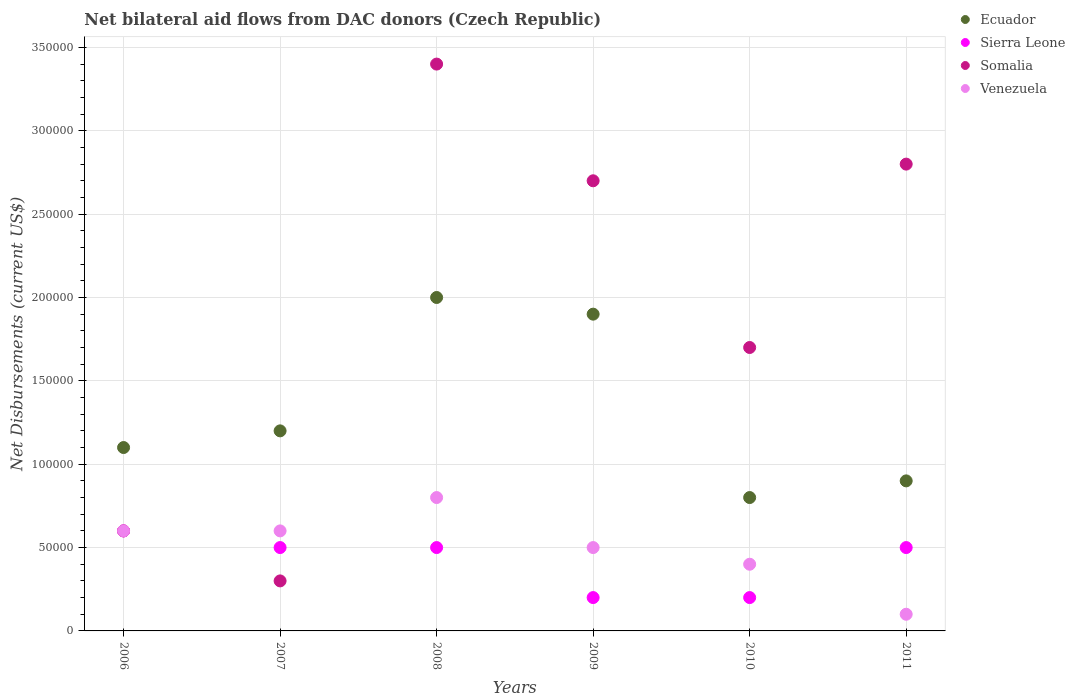Is the number of dotlines equal to the number of legend labels?
Your answer should be compact. Yes. What is the net bilateral aid flows in Somalia in 2010?
Your response must be concise. 1.70e+05. In which year was the net bilateral aid flows in Ecuador maximum?
Provide a short and direct response. 2008. What is the total net bilateral aid flows in Sierra Leone in the graph?
Offer a very short reply. 2.50e+05. In how many years, is the net bilateral aid flows in Ecuador greater than 340000 US$?
Make the answer very short. 0. What is the ratio of the net bilateral aid flows in Venezuela in 2007 to that in 2008?
Keep it short and to the point. 0.75. Is the net bilateral aid flows in Ecuador in 2008 less than that in 2009?
Ensure brevity in your answer.  No. Is the sum of the net bilateral aid flows in Somalia in 2007 and 2011 greater than the maximum net bilateral aid flows in Sierra Leone across all years?
Your answer should be compact. Yes. Does the net bilateral aid flows in Sierra Leone monotonically increase over the years?
Provide a short and direct response. No. Is the net bilateral aid flows in Sierra Leone strictly greater than the net bilateral aid flows in Ecuador over the years?
Make the answer very short. No. How many years are there in the graph?
Your answer should be compact. 6. Does the graph contain grids?
Keep it short and to the point. Yes. How many legend labels are there?
Provide a short and direct response. 4. How are the legend labels stacked?
Your answer should be compact. Vertical. What is the title of the graph?
Offer a terse response. Net bilateral aid flows from DAC donors (Czech Republic). Does "Cayman Islands" appear as one of the legend labels in the graph?
Your answer should be very brief. No. What is the label or title of the X-axis?
Your answer should be very brief. Years. What is the label or title of the Y-axis?
Provide a succinct answer. Net Disbursements (current US$). What is the Net Disbursements (current US$) of Sierra Leone in 2006?
Offer a terse response. 6.00e+04. What is the Net Disbursements (current US$) of Somalia in 2006?
Offer a very short reply. 6.00e+04. What is the Net Disbursements (current US$) in Ecuador in 2007?
Make the answer very short. 1.20e+05. What is the Net Disbursements (current US$) in Sierra Leone in 2007?
Give a very brief answer. 5.00e+04. What is the Net Disbursements (current US$) of Venezuela in 2007?
Keep it short and to the point. 6.00e+04. What is the Net Disbursements (current US$) of Ecuador in 2008?
Provide a short and direct response. 2.00e+05. What is the Net Disbursements (current US$) of Venezuela in 2008?
Ensure brevity in your answer.  8.00e+04. What is the Net Disbursements (current US$) in Sierra Leone in 2009?
Make the answer very short. 2.00e+04. What is the Net Disbursements (current US$) of Somalia in 2009?
Keep it short and to the point. 2.70e+05. What is the Net Disbursements (current US$) in Ecuador in 2010?
Make the answer very short. 8.00e+04. What is the Net Disbursements (current US$) of Sierra Leone in 2010?
Provide a succinct answer. 2.00e+04. What is the Net Disbursements (current US$) of Somalia in 2010?
Give a very brief answer. 1.70e+05. What is the Net Disbursements (current US$) of Ecuador in 2011?
Provide a short and direct response. 9.00e+04. What is the Net Disbursements (current US$) of Venezuela in 2011?
Keep it short and to the point. 10000. Across all years, what is the maximum Net Disbursements (current US$) of Ecuador?
Offer a very short reply. 2.00e+05. Across all years, what is the minimum Net Disbursements (current US$) of Ecuador?
Your answer should be very brief. 8.00e+04. Across all years, what is the minimum Net Disbursements (current US$) of Sierra Leone?
Give a very brief answer. 2.00e+04. What is the total Net Disbursements (current US$) in Ecuador in the graph?
Offer a terse response. 7.90e+05. What is the total Net Disbursements (current US$) in Somalia in the graph?
Give a very brief answer. 1.15e+06. What is the difference between the Net Disbursements (current US$) in Somalia in 2006 and that in 2007?
Your answer should be compact. 3.00e+04. What is the difference between the Net Disbursements (current US$) in Venezuela in 2006 and that in 2007?
Offer a very short reply. 0. What is the difference between the Net Disbursements (current US$) of Sierra Leone in 2006 and that in 2008?
Your answer should be very brief. 10000. What is the difference between the Net Disbursements (current US$) in Somalia in 2006 and that in 2008?
Offer a terse response. -2.80e+05. What is the difference between the Net Disbursements (current US$) in Venezuela in 2006 and that in 2008?
Make the answer very short. -2.00e+04. What is the difference between the Net Disbursements (current US$) in Sierra Leone in 2006 and that in 2009?
Your answer should be very brief. 4.00e+04. What is the difference between the Net Disbursements (current US$) of Ecuador in 2006 and that in 2010?
Your response must be concise. 3.00e+04. What is the difference between the Net Disbursements (current US$) of Somalia in 2006 and that in 2011?
Provide a short and direct response. -2.20e+05. What is the difference between the Net Disbursements (current US$) of Venezuela in 2006 and that in 2011?
Make the answer very short. 5.00e+04. What is the difference between the Net Disbursements (current US$) in Sierra Leone in 2007 and that in 2008?
Give a very brief answer. 0. What is the difference between the Net Disbursements (current US$) in Somalia in 2007 and that in 2008?
Keep it short and to the point. -3.10e+05. What is the difference between the Net Disbursements (current US$) in Ecuador in 2007 and that in 2009?
Ensure brevity in your answer.  -7.00e+04. What is the difference between the Net Disbursements (current US$) of Somalia in 2007 and that in 2009?
Keep it short and to the point. -2.40e+05. What is the difference between the Net Disbursements (current US$) in Venezuela in 2007 and that in 2009?
Your answer should be very brief. 10000. What is the difference between the Net Disbursements (current US$) in Ecuador in 2007 and that in 2011?
Give a very brief answer. 3.00e+04. What is the difference between the Net Disbursements (current US$) in Somalia in 2007 and that in 2011?
Provide a short and direct response. -2.50e+05. What is the difference between the Net Disbursements (current US$) in Venezuela in 2007 and that in 2011?
Make the answer very short. 5.00e+04. What is the difference between the Net Disbursements (current US$) in Sierra Leone in 2008 and that in 2009?
Your response must be concise. 3.00e+04. What is the difference between the Net Disbursements (current US$) of Venezuela in 2008 and that in 2009?
Provide a succinct answer. 3.00e+04. What is the difference between the Net Disbursements (current US$) of Ecuador in 2008 and that in 2010?
Give a very brief answer. 1.20e+05. What is the difference between the Net Disbursements (current US$) in Sierra Leone in 2008 and that in 2010?
Provide a short and direct response. 3.00e+04. What is the difference between the Net Disbursements (current US$) in Venezuela in 2008 and that in 2010?
Keep it short and to the point. 4.00e+04. What is the difference between the Net Disbursements (current US$) in Sierra Leone in 2008 and that in 2011?
Provide a short and direct response. 0. What is the difference between the Net Disbursements (current US$) in Somalia in 2008 and that in 2011?
Keep it short and to the point. 6.00e+04. What is the difference between the Net Disbursements (current US$) of Venezuela in 2008 and that in 2011?
Ensure brevity in your answer.  7.00e+04. What is the difference between the Net Disbursements (current US$) in Venezuela in 2009 and that in 2010?
Your answer should be very brief. 10000. What is the difference between the Net Disbursements (current US$) in Ecuador in 2009 and that in 2011?
Keep it short and to the point. 1.00e+05. What is the difference between the Net Disbursements (current US$) in Sierra Leone in 2009 and that in 2011?
Provide a short and direct response. -3.00e+04. What is the difference between the Net Disbursements (current US$) in Somalia in 2009 and that in 2011?
Your answer should be very brief. -10000. What is the difference between the Net Disbursements (current US$) of Ecuador in 2010 and that in 2011?
Offer a terse response. -10000. What is the difference between the Net Disbursements (current US$) in Somalia in 2010 and that in 2011?
Provide a short and direct response. -1.10e+05. What is the difference between the Net Disbursements (current US$) in Ecuador in 2006 and the Net Disbursements (current US$) in Sierra Leone in 2007?
Your answer should be very brief. 6.00e+04. What is the difference between the Net Disbursements (current US$) in Ecuador in 2006 and the Net Disbursements (current US$) in Somalia in 2007?
Provide a short and direct response. 8.00e+04. What is the difference between the Net Disbursements (current US$) in Ecuador in 2006 and the Net Disbursements (current US$) in Venezuela in 2007?
Your answer should be compact. 5.00e+04. What is the difference between the Net Disbursements (current US$) in Sierra Leone in 2006 and the Net Disbursements (current US$) in Venezuela in 2007?
Your answer should be very brief. 0. What is the difference between the Net Disbursements (current US$) of Ecuador in 2006 and the Net Disbursements (current US$) of Sierra Leone in 2008?
Make the answer very short. 6.00e+04. What is the difference between the Net Disbursements (current US$) of Ecuador in 2006 and the Net Disbursements (current US$) of Somalia in 2008?
Offer a very short reply. -2.30e+05. What is the difference between the Net Disbursements (current US$) in Sierra Leone in 2006 and the Net Disbursements (current US$) in Somalia in 2008?
Offer a terse response. -2.80e+05. What is the difference between the Net Disbursements (current US$) of Somalia in 2006 and the Net Disbursements (current US$) of Venezuela in 2008?
Give a very brief answer. -2.00e+04. What is the difference between the Net Disbursements (current US$) in Ecuador in 2006 and the Net Disbursements (current US$) in Venezuela in 2009?
Offer a terse response. 6.00e+04. What is the difference between the Net Disbursements (current US$) of Sierra Leone in 2006 and the Net Disbursements (current US$) of Somalia in 2009?
Offer a terse response. -2.10e+05. What is the difference between the Net Disbursements (current US$) of Sierra Leone in 2006 and the Net Disbursements (current US$) of Venezuela in 2009?
Your response must be concise. 10000. What is the difference between the Net Disbursements (current US$) in Somalia in 2006 and the Net Disbursements (current US$) in Venezuela in 2009?
Give a very brief answer. 10000. What is the difference between the Net Disbursements (current US$) in Ecuador in 2006 and the Net Disbursements (current US$) in Sierra Leone in 2010?
Provide a short and direct response. 9.00e+04. What is the difference between the Net Disbursements (current US$) of Ecuador in 2006 and the Net Disbursements (current US$) of Venezuela in 2010?
Offer a terse response. 7.00e+04. What is the difference between the Net Disbursements (current US$) of Sierra Leone in 2006 and the Net Disbursements (current US$) of Somalia in 2010?
Your answer should be very brief. -1.10e+05. What is the difference between the Net Disbursements (current US$) in Somalia in 2006 and the Net Disbursements (current US$) in Venezuela in 2010?
Your response must be concise. 2.00e+04. What is the difference between the Net Disbursements (current US$) of Ecuador in 2006 and the Net Disbursements (current US$) of Sierra Leone in 2011?
Keep it short and to the point. 6.00e+04. What is the difference between the Net Disbursements (current US$) in Sierra Leone in 2006 and the Net Disbursements (current US$) in Venezuela in 2011?
Your answer should be compact. 5.00e+04. What is the difference between the Net Disbursements (current US$) in Ecuador in 2007 and the Net Disbursements (current US$) in Somalia in 2008?
Offer a terse response. -2.20e+05. What is the difference between the Net Disbursements (current US$) of Sierra Leone in 2007 and the Net Disbursements (current US$) of Somalia in 2008?
Offer a terse response. -2.90e+05. What is the difference between the Net Disbursements (current US$) of Sierra Leone in 2007 and the Net Disbursements (current US$) of Venezuela in 2008?
Make the answer very short. -3.00e+04. What is the difference between the Net Disbursements (current US$) of Ecuador in 2007 and the Net Disbursements (current US$) of Sierra Leone in 2009?
Your response must be concise. 1.00e+05. What is the difference between the Net Disbursements (current US$) in Ecuador in 2007 and the Net Disbursements (current US$) in Somalia in 2010?
Provide a succinct answer. -5.00e+04. What is the difference between the Net Disbursements (current US$) of Ecuador in 2007 and the Net Disbursements (current US$) of Venezuela in 2010?
Ensure brevity in your answer.  8.00e+04. What is the difference between the Net Disbursements (current US$) in Sierra Leone in 2007 and the Net Disbursements (current US$) in Somalia in 2011?
Offer a terse response. -2.30e+05. What is the difference between the Net Disbursements (current US$) of Ecuador in 2008 and the Net Disbursements (current US$) of Somalia in 2009?
Ensure brevity in your answer.  -7.00e+04. What is the difference between the Net Disbursements (current US$) in Sierra Leone in 2008 and the Net Disbursements (current US$) in Somalia in 2009?
Offer a very short reply. -2.20e+05. What is the difference between the Net Disbursements (current US$) in Somalia in 2008 and the Net Disbursements (current US$) in Venezuela in 2009?
Offer a very short reply. 2.90e+05. What is the difference between the Net Disbursements (current US$) of Ecuador in 2008 and the Net Disbursements (current US$) of Somalia in 2010?
Provide a short and direct response. 3.00e+04. What is the difference between the Net Disbursements (current US$) in Ecuador in 2008 and the Net Disbursements (current US$) in Venezuela in 2010?
Keep it short and to the point. 1.60e+05. What is the difference between the Net Disbursements (current US$) of Somalia in 2008 and the Net Disbursements (current US$) of Venezuela in 2010?
Make the answer very short. 3.00e+05. What is the difference between the Net Disbursements (current US$) of Ecuador in 2008 and the Net Disbursements (current US$) of Sierra Leone in 2011?
Your answer should be very brief. 1.50e+05. What is the difference between the Net Disbursements (current US$) in Ecuador in 2008 and the Net Disbursements (current US$) in Somalia in 2011?
Your answer should be compact. -8.00e+04. What is the difference between the Net Disbursements (current US$) in Ecuador in 2008 and the Net Disbursements (current US$) in Venezuela in 2011?
Offer a terse response. 1.90e+05. What is the difference between the Net Disbursements (current US$) of Sierra Leone in 2008 and the Net Disbursements (current US$) of Somalia in 2011?
Keep it short and to the point. -2.30e+05. What is the difference between the Net Disbursements (current US$) of Somalia in 2008 and the Net Disbursements (current US$) of Venezuela in 2011?
Provide a succinct answer. 3.30e+05. What is the difference between the Net Disbursements (current US$) of Ecuador in 2009 and the Net Disbursements (current US$) of Somalia in 2010?
Provide a succinct answer. 2.00e+04. What is the difference between the Net Disbursements (current US$) of Somalia in 2009 and the Net Disbursements (current US$) of Venezuela in 2010?
Give a very brief answer. 2.30e+05. What is the difference between the Net Disbursements (current US$) in Ecuador in 2009 and the Net Disbursements (current US$) in Sierra Leone in 2011?
Your answer should be very brief. 1.40e+05. What is the difference between the Net Disbursements (current US$) of Ecuador in 2009 and the Net Disbursements (current US$) of Somalia in 2011?
Provide a succinct answer. -9.00e+04. What is the difference between the Net Disbursements (current US$) in Sierra Leone in 2009 and the Net Disbursements (current US$) in Venezuela in 2011?
Ensure brevity in your answer.  10000. What is the difference between the Net Disbursements (current US$) of Ecuador in 2010 and the Net Disbursements (current US$) of Sierra Leone in 2011?
Provide a succinct answer. 3.00e+04. What is the difference between the Net Disbursements (current US$) of Ecuador in 2010 and the Net Disbursements (current US$) of Somalia in 2011?
Offer a very short reply. -2.00e+05. What is the difference between the Net Disbursements (current US$) of Somalia in 2010 and the Net Disbursements (current US$) of Venezuela in 2011?
Your response must be concise. 1.60e+05. What is the average Net Disbursements (current US$) in Ecuador per year?
Provide a short and direct response. 1.32e+05. What is the average Net Disbursements (current US$) of Sierra Leone per year?
Give a very brief answer. 4.17e+04. What is the average Net Disbursements (current US$) in Somalia per year?
Ensure brevity in your answer.  1.92e+05. In the year 2006, what is the difference between the Net Disbursements (current US$) in Ecuador and Net Disbursements (current US$) in Sierra Leone?
Provide a short and direct response. 5.00e+04. In the year 2006, what is the difference between the Net Disbursements (current US$) of Ecuador and Net Disbursements (current US$) of Venezuela?
Make the answer very short. 5.00e+04. In the year 2006, what is the difference between the Net Disbursements (current US$) in Somalia and Net Disbursements (current US$) in Venezuela?
Provide a short and direct response. 0. In the year 2007, what is the difference between the Net Disbursements (current US$) of Ecuador and Net Disbursements (current US$) of Sierra Leone?
Your answer should be very brief. 7.00e+04. In the year 2007, what is the difference between the Net Disbursements (current US$) of Ecuador and Net Disbursements (current US$) of Venezuela?
Make the answer very short. 6.00e+04. In the year 2007, what is the difference between the Net Disbursements (current US$) of Somalia and Net Disbursements (current US$) of Venezuela?
Make the answer very short. -3.00e+04. In the year 2008, what is the difference between the Net Disbursements (current US$) of Ecuador and Net Disbursements (current US$) of Venezuela?
Your answer should be very brief. 1.20e+05. In the year 2009, what is the difference between the Net Disbursements (current US$) in Ecuador and Net Disbursements (current US$) in Sierra Leone?
Provide a short and direct response. 1.70e+05. In the year 2009, what is the difference between the Net Disbursements (current US$) of Ecuador and Net Disbursements (current US$) of Somalia?
Keep it short and to the point. -8.00e+04. In the year 2009, what is the difference between the Net Disbursements (current US$) in Ecuador and Net Disbursements (current US$) in Venezuela?
Offer a very short reply. 1.40e+05. In the year 2009, what is the difference between the Net Disbursements (current US$) of Sierra Leone and Net Disbursements (current US$) of Somalia?
Provide a short and direct response. -2.50e+05. In the year 2009, what is the difference between the Net Disbursements (current US$) in Somalia and Net Disbursements (current US$) in Venezuela?
Offer a terse response. 2.20e+05. In the year 2010, what is the difference between the Net Disbursements (current US$) in Ecuador and Net Disbursements (current US$) in Sierra Leone?
Offer a terse response. 6.00e+04. In the year 2010, what is the difference between the Net Disbursements (current US$) in Ecuador and Net Disbursements (current US$) in Venezuela?
Your answer should be compact. 4.00e+04. In the year 2010, what is the difference between the Net Disbursements (current US$) of Sierra Leone and Net Disbursements (current US$) of Somalia?
Your response must be concise. -1.50e+05. In the year 2010, what is the difference between the Net Disbursements (current US$) of Sierra Leone and Net Disbursements (current US$) of Venezuela?
Ensure brevity in your answer.  -2.00e+04. In the year 2011, what is the difference between the Net Disbursements (current US$) in Ecuador and Net Disbursements (current US$) in Sierra Leone?
Offer a very short reply. 4.00e+04. In the year 2011, what is the difference between the Net Disbursements (current US$) of Ecuador and Net Disbursements (current US$) of Somalia?
Make the answer very short. -1.90e+05. In the year 2011, what is the difference between the Net Disbursements (current US$) in Sierra Leone and Net Disbursements (current US$) in Venezuela?
Give a very brief answer. 4.00e+04. In the year 2011, what is the difference between the Net Disbursements (current US$) of Somalia and Net Disbursements (current US$) of Venezuela?
Offer a very short reply. 2.70e+05. What is the ratio of the Net Disbursements (current US$) of Ecuador in 2006 to that in 2007?
Your answer should be compact. 0.92. What is the ratio of the Net Disbursements (current US$) in Somalia in 2006 to that in 2007?
Your response must be concise. 2. What is the ratio of the Net Disbursements (current US$) of Venezuela in 2006 to that in 2007?
Your answer should be very brief. 1. What is the ratio of the Net Disbursements (current US$) of Ecuador in 2006 to that in 2008?
Ensure brevity in your answer.  0.55. What is the ratio of the Net Disbursements (current US$) of Sierra Leone in 2006 to that in 2008?
Give a very brief answer. 1.2. What is the ratio of the Net Disbursements (current US$) in Somalia in 2006 to that in 2008?
Make the answer very short. 0.18. What is the ratio of the Net Disbursements (current US$) in Ecuador in 2006 to that in 2009?
Ensure brevity in your answer.  0.58. What is the ratio of the Net Disbursements (current US$) in Somalia in 2006 to that in 2009?
Ensure brevity in your answer.  0.22. What is the ratio of the Net Disbursements (current US$) in Venezuela in 2006 to that in 2009?
Your answer should be very brief. 1.2. What is the ratio of the Net Disbursements (current US$) of Ecuador in 2006 to that in 2010?
Your answer should be compact. 1.38. What is the ratio of the Net Disbursements (current US$) of Somalia in 2006 to that in 2010?
Make the answer very short. 0.35. What is the ratio of the Net Disbursements (current US$) in Ecuador in 2006 to that in 2011?
Offer a very short reply. 1.22. What is the ratio of the Net Disbursements (current US$) of Somalia in 2006 to that in 2011?
Your response must be concise. 0.21. What is the ratio of the Net Disbursements (current US$) in Ecuador in 2007 to that in 2008?
Give a very brief answer. 0.6. What is the ratio of the Net Disbursements (current US$) of Sierra Leone in 2007 to that in 2008?
Your response must be concise. 1. What is the ratio of the Net Disbursements (current US$) in Somalia in 2007 to that in 2008?
Offer a very short reply. 0.09. What is the ratio of the Net Disbursements (current US$) in Ecuador in 2007 to that in 2009?
Your response must be concise. 0.63. What is the ratio of the Net Disbursements (current US$) in Somalia in 2007 to that in 2009?
Your response must be concise. 0.11. What is the ratio of the Net Disbursements (current US$) of Venezuela in 2007 to that in 2009?
Provide a succinct answer. 1.2. What is the ratio of the Net Disbursements (current US$) in Somalia in 2007 to that in 2010?
Ensure brevity in your answer.  0.18. What is the ratio of the Net Disbursements (current US$) in Venezuela in 2007 to that in 2010?
Offer a terse response. 1.5. What is the ratio of the Net Disbursements (current US$) of Sierra Leone in 2007 to that in 2011?
Offer a terse response. 1. What is the ratio of the Net Disbursements (current US$) in Somalia in 2007 to that in 2011?
Your answer should be compact. 0.11. What is the ratio of the Net Disbursements (current US$) of Venezuela in 2007 to that in 2011?
Provide a short and direct response. 6. What is the ratio of the Net Disbursements (current US$) in Ecuador in 2008 to that in 2009?
Your answer should be compact. 1.05. What is the ratio of the Net Disbursements (current US$) of Somalia in 2008 to that in 2009?
Provide a short and direct response. 1.26. What is the ratio of the Net Disbursements (current US$) of Venezuela in 2008 to that in 2009?
Keep it short and to the point. 1.6. What is the ratio of the Net Disbursements (current US$) in Somalia in 2008 to that in 2010?
Make the answer very short. 2. What is the ratio of the Net Disbursements (current US$) of Venezuela in 2008 to that in 2010?
Offer a terse response. 2. What is the ratio of the Net Disbursements (current US$) in Ecuador in 2008 to that in 2011?
Offer a very short reply. 2.22. What is the ratio of the Net Disbursements (current US$) in Sierra Leone in 2008 to that in 2011?
Provide a succinct answer. 1. What is the ratio of the Net Disbursements (current US$) in Somalia in 2008 to that in 2011?
Give a very brief answer. 1.21. What is the ratio of the Net Disbursements (current US$) in Venezuela in 2008 to that in 2011?
Your answer should be compact. 8. What is the ratio of the Net Disbursements (current US$) in Ecuador in 2009 to that in 2010?
Offer a very short reply. 2.38. What is the ratio of the Net Disbursements (current US$) in Sierra Leone in 2009 to that in 2010?
Provide a succinct answer. 1. What is the ratio of the Net Disbursements (current US$) of Somalia in 2009 to that in 2010?
Your answer should be compact. 1.59. What is the ratio of the Net Disbursements (current US$) in Ecuador in 2009 to that in 2011?
Offer a terse response. 2.11. What is the ratio of the Net Disbursements (current US$) in Sierra Leone in 2009 to that in 2011?
Your answer should be very brief. 0.4. What is the ratio of the Net Disbursements (current US$) in Somalia in 2009 to that in 2011?
Keep it short and to the point. 0.96. What is the ratio of the Net Disbursements (current US$) of Sierra Leone in 2010 to that in 2011?
Provide a succinct answer. 0.4. What is the ratio of the Net Disbursements (current US$) of Somalia in 2010 to that in 2011?
Offer a terse response. 0.61. What is the ratio of the Net Disbursements (current US$) of Venezuela in 2010 to that in 2011?
Offer a terse response. 4. What is the difference between the highest and the second highest Net Disbursements (current US$) in Sierra Leone?
Make the answer very short. 10000. What is the difference between the highest and the second highest Net Disbursements (current US$) in Somalia?
Your answer should be compact. 6.00e+04. What is the difference between the highest and the lowest Net Disbursements (current US$) in Ecuador?
Provide a short and direct response. 1.20e+05. What is the difference between the highest and the lowest Net Disbursements (current US$) of Somalia?
Your answer should be very brief. 3.10e+05. 